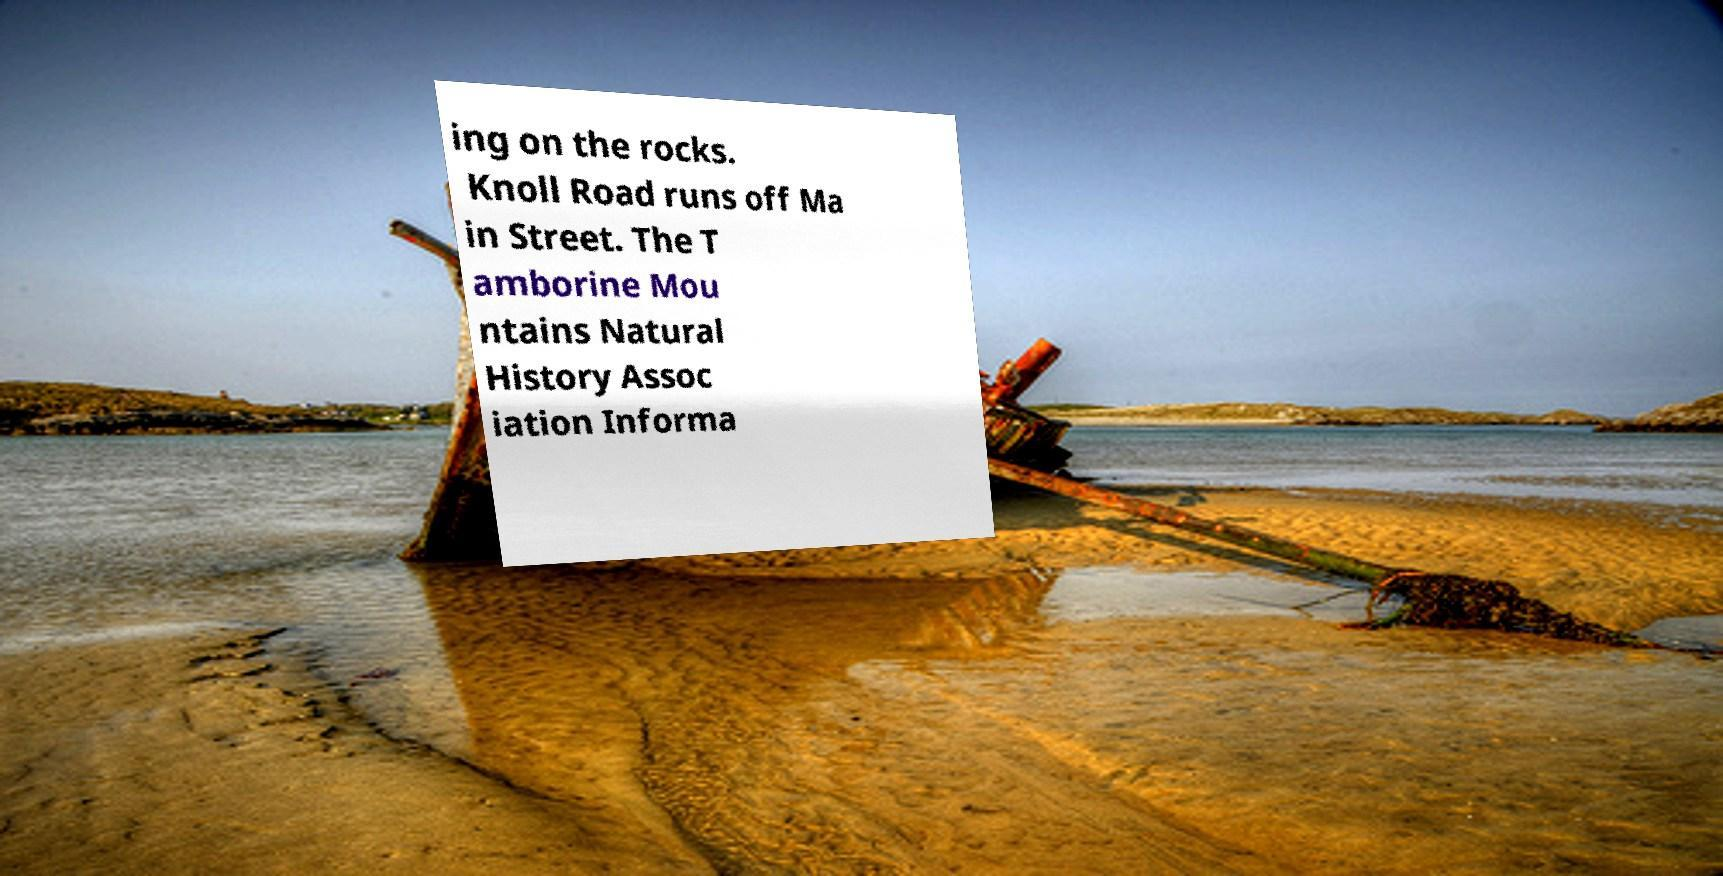Please identify and transcribe the text found in this image. ing on the rocks. Knoll Road runs off Ma in Street. The T amborine Mou ntains Natural History Assoc iation Informa 